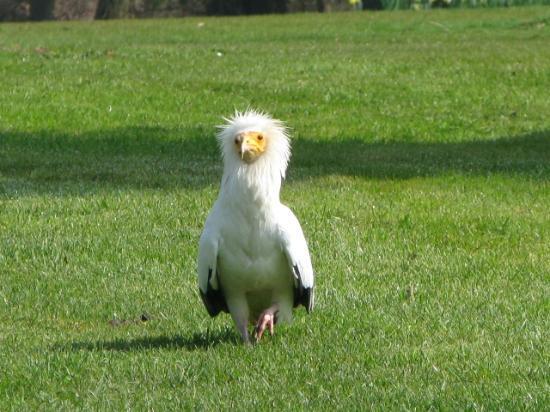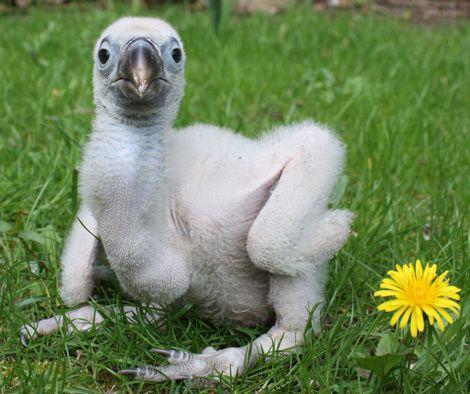The first image is the image on the left, the second image is the image on the right. For the images displayed, is the sentence "The images contain baby birds" factually correct? Answer yes or no. Yes. 